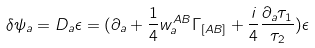<formula> <loc_0><loc_0><loc_500><loc_500>\delta \psi _ { a } = D _ { a } \epsilon = ( \partial _ { a } + \frac { 1 } { 4 } w ^ { A B } _ { a } \Gamma _ { [ A B ] } + \frac { i } { 4 } \frac { \partial _ { a } \tau _ { 1 } } { \tau _ { 2 } } ) \epsilon</formula> 